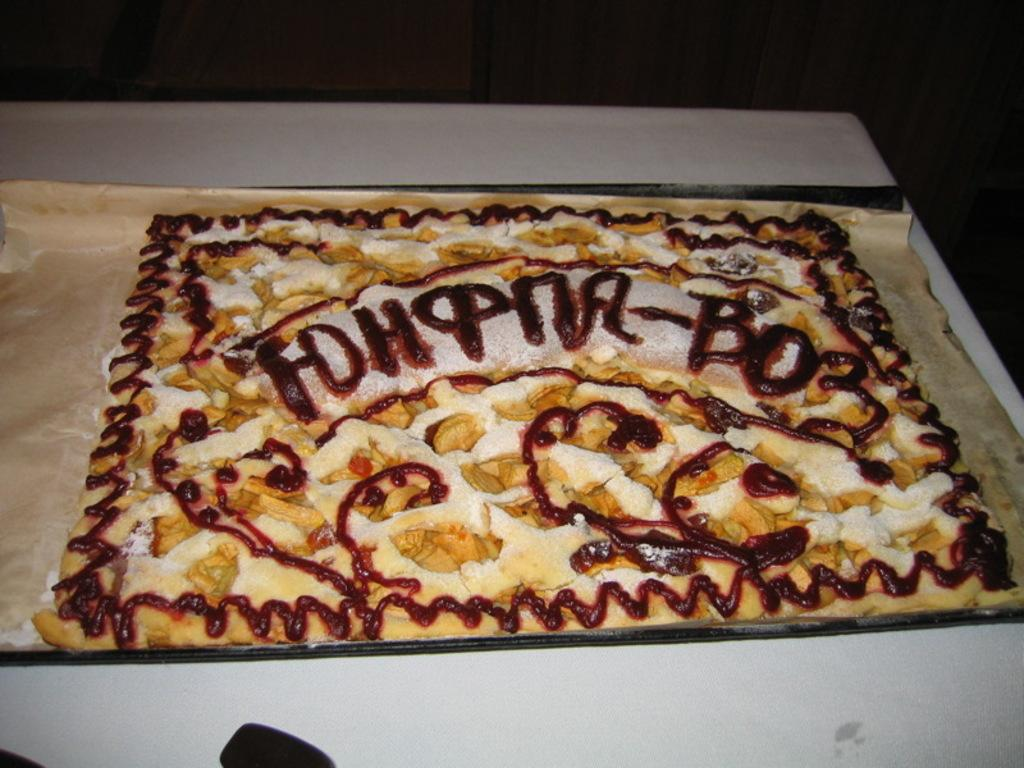What type of food item is visible in the image? There is a food item in the image, and it is decorated with fruit jam. How is the food item presented in the image? The food item is placed on a tray. What is the color of the table in the image? The table in the image is white in color. How many chairs are visible in the image? There are no chairs visible in the image. Is there a train passing by in the background of the image? There is no train present in the image. 